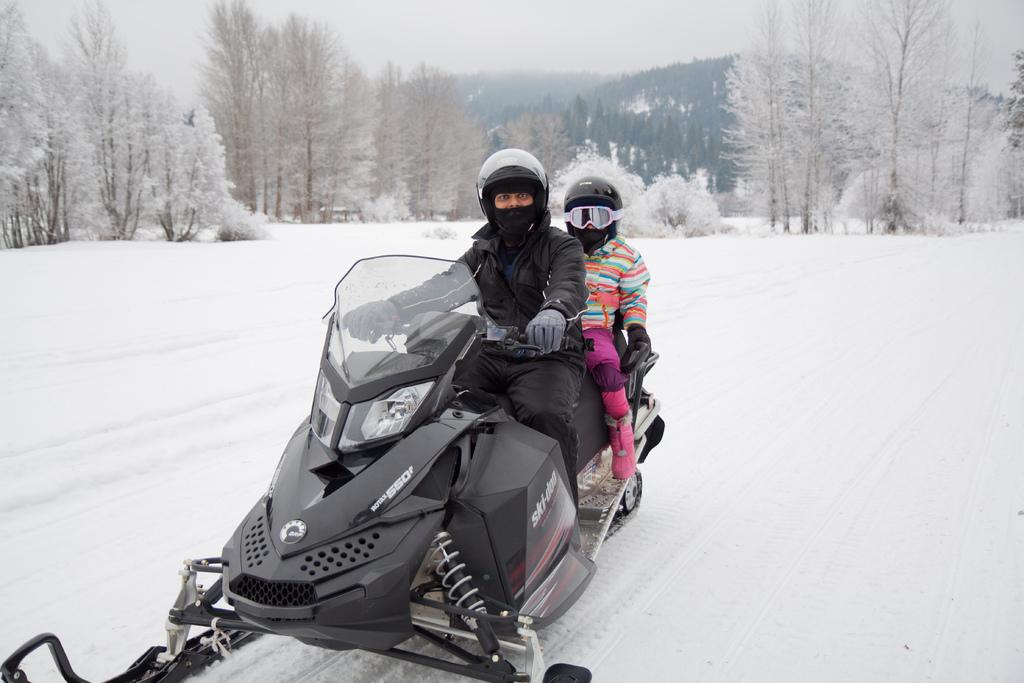How many people are in the image? There are two persons in the image. What are the persons doing in the image? The persons are riding a vehicle. What is the terrain like in the image? The vehicle is on the snow. What can be seen in the background of the image? There are trees and the sky visible in the background of the image. What type of surprise can be seen in the image? There is no surprise present in the image. Are the persons in the image slipping on the snow? The image does not show the persons slipping on the snow; they are riding a vehicle on the snow. 